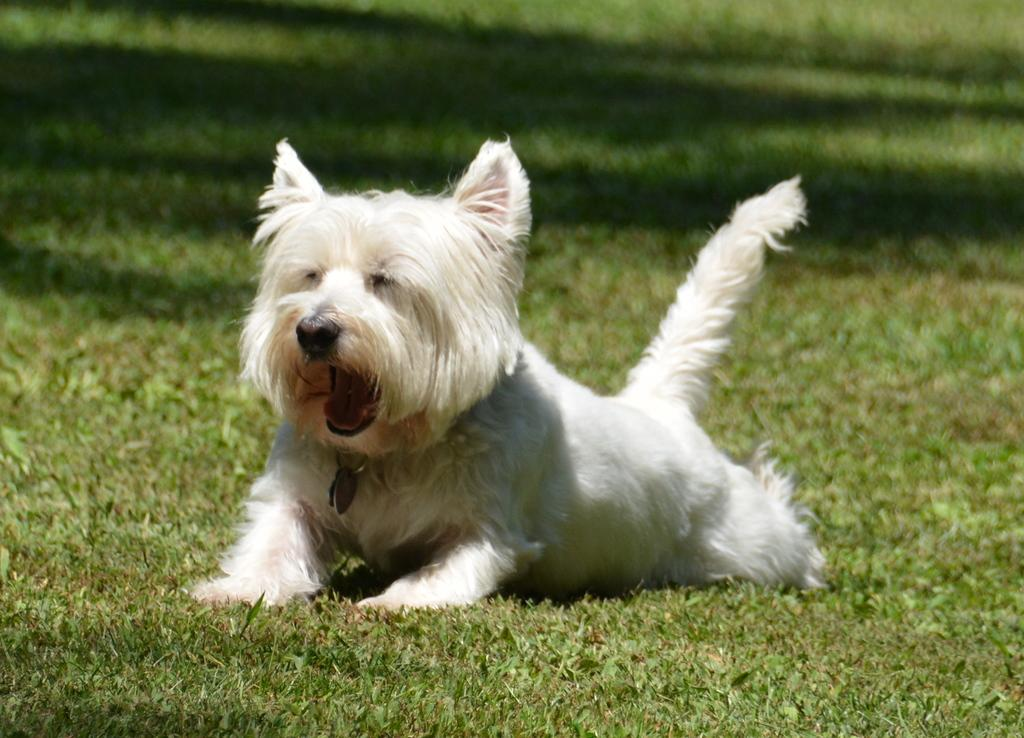What animal is present in the image? There is a dog in the picture. What is the color of the dog? The dog is white in color. Where is the dog located in the image? The dog is on a greenery ground. What type of song is the dog singing in the image? There is no indication in the image that the dog is singing a song, as dogs do not have the ability to sing. 